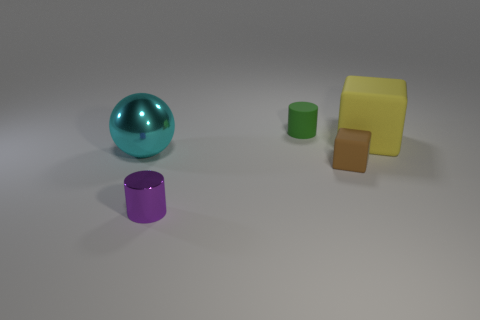What number of metallic cylinders are the same size as the brown rubber cube?
Your answer should be compact. 1. There is a big sphere that is made of the same material as the purple cylinder; what is its color?
Your response must be concise. Cyan. Is the number of large gray rubber things less than the number of rubber cubes?
Your answer should be very brief. Yes. How many blue objects are either tiny matte balls or large balls?
Your answer should be very brief. 0. How many things are both on the right side of the small brown matte object and on the left side of the yellow rubber thing?
Provide a short and direct response. 0. Does the green object have the same material as the tiny brown thing?
Ensure brevity in your answer.  Yes. There is a green matte thing that is the same size as the brown thing; what shape is it?
Ensure brevity in your answer.  Cylinder. Is the number of big cyan metal spheres greater than the number of big purple rubber blocks?
Offer a terse response. Yes. The object that is both left of the green cylinder and in front of the big cyan sphere is made of what material?
Offer a terse response. Metal. How many other things are there of the same material as the small brown thing?
Keep it short and to the point. 2. 